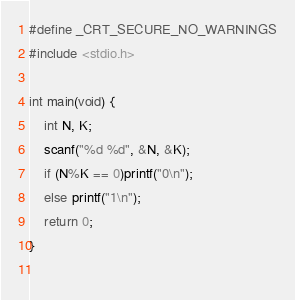Convert code to text. <code><loc_0><loc_0><loc_500><loc_500><_C++_>#define _CRT_SECURE_NO_WARNINGS
#include <stdio.h>

int main(void) {
	int N, K;
	scanf("%d %d", &N, &K);
	if (N%K == 0)printf("0\n");
	else printf("1\n");
	return 0;
}
 </code> 